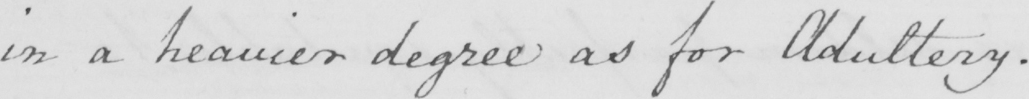What is written in this line of handwriting? in a heavier degree as for Adultery . 